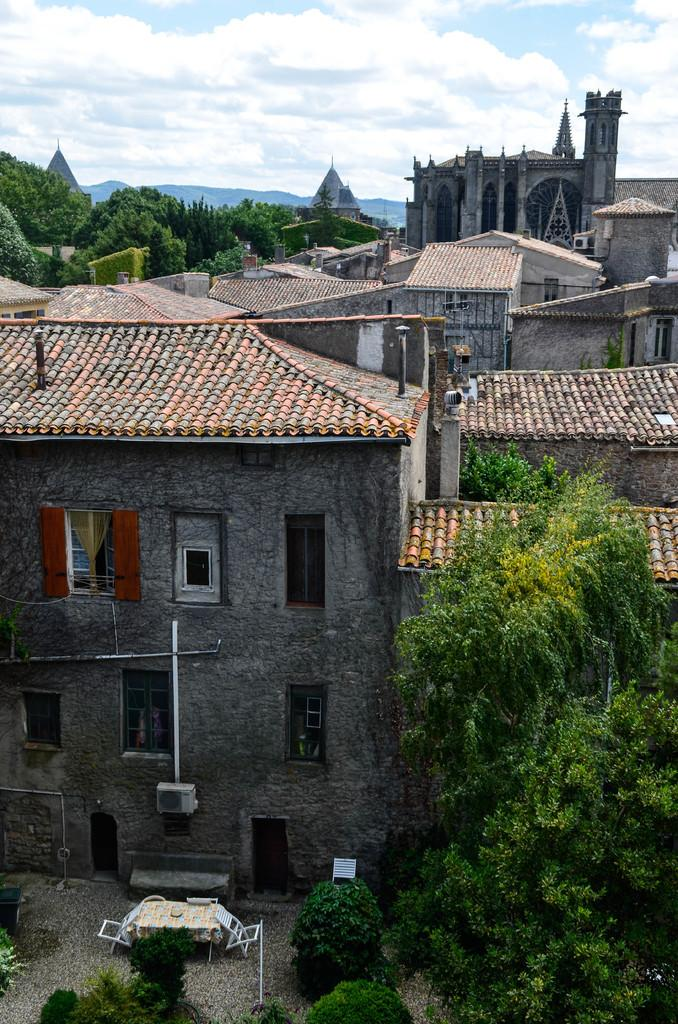What type of structures can be seen in the image? There are buildings in the image. What other natural elements are present in the image? There are trees in the image. What can be seen in the distance in the image? Hills are visible in the background of the image. What is visible in the sky in the image? The sky is visible in the background of the image, and clouds are present. What type of fire can be seen burning on the scale in the image? There is no fire or scale present in the image. 